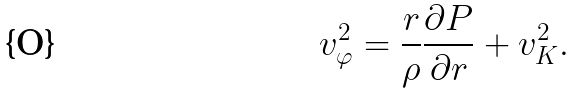<formula> <loc_0><loc_0><loc_500><loc_500>v _ { \varphi } ^ { 2 } = \frac { r } { \rho } \frac { \partial P } { \partial r } + v _ { K } ^ { 2 } .</formula> 